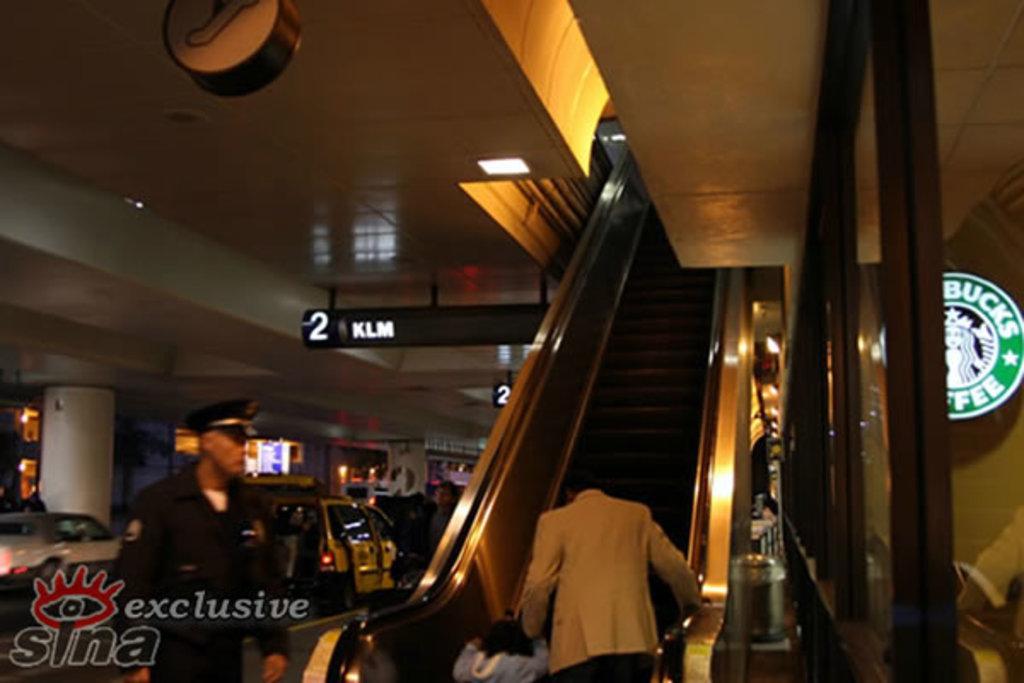In one or two sentences, can you explain what this image depicts? In this image we can see persons on the escalator, information boards, motor vehicles and name boards. 